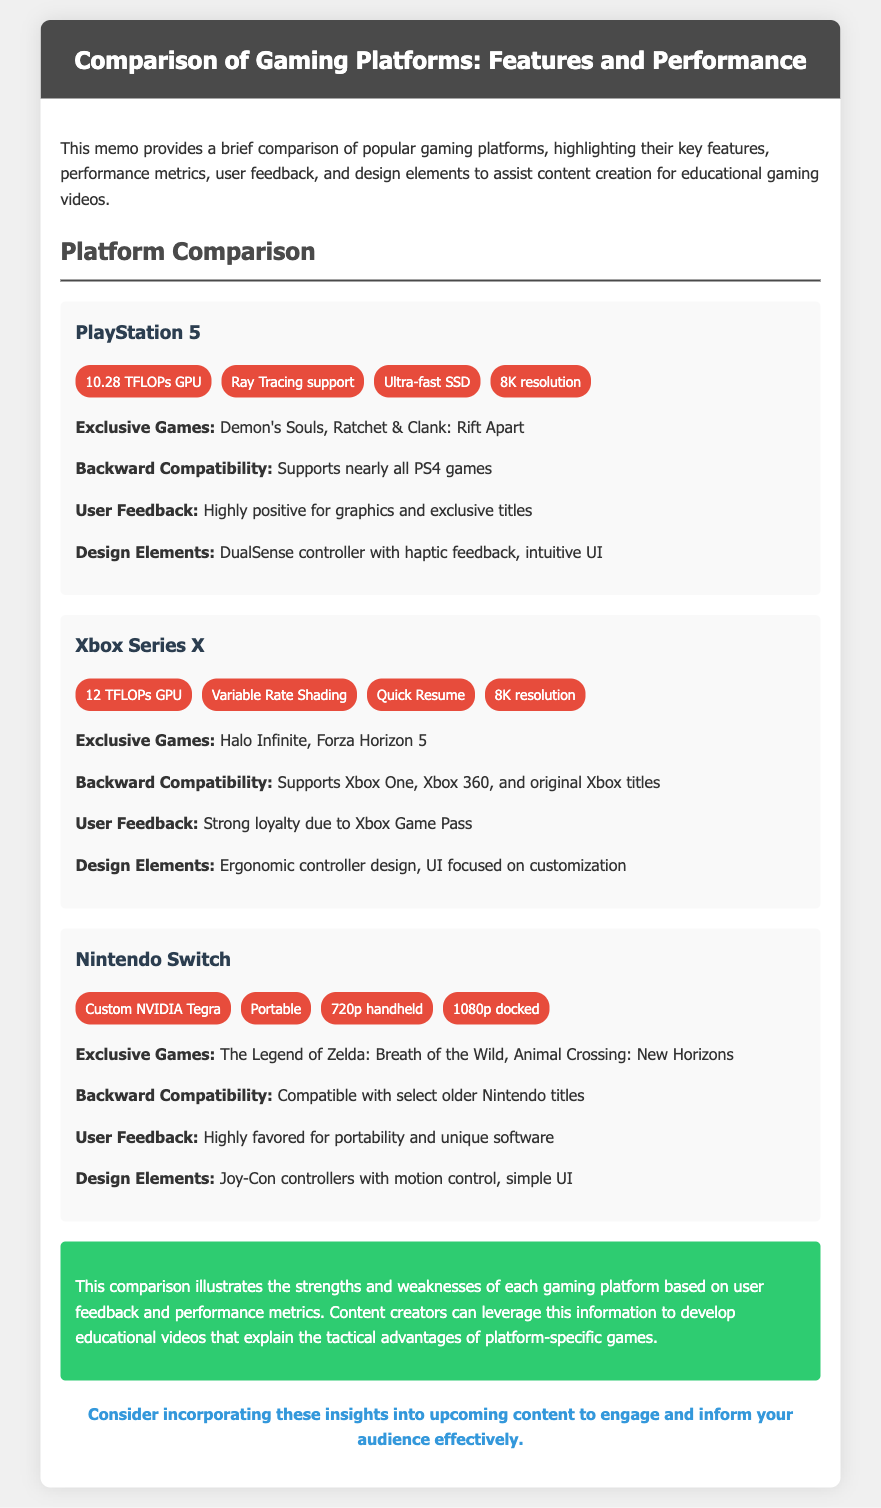What is the GPU power of PlayStation 5? The document lists the GPU power of PlayStation 5 as 10.28 TFLOPs.
Answer: 10.28 TFLOPs What exclusive game is mentioned for the Xbox Series X? The document specifically mentions Halo Infinite as an exclusive game for Xbox Series X.
Answer: Halo Infinite What is the maximum resolution supported by Xbox Series X? The document states that Xbox Series X supports up to 8K resolution.
Answer: 8K resolution Which platform is favored for its portability? The Nintendo Switch is highlighted in the document as being highly favored for its portability.
Answer: Nintendo Switch What feature allows quick game resuming on Xbox Series X? The feature "Quick Resume" is mentioned for Xbox Series X, facilitating quick game resuming.
Answer: Quick Resume Which platform has the most powerful GPU based on TFLOPs? The comparison shows Xbox Series X having the most powerful GPU with 12 TFLOPs.
Answer: 12 TFLOPs What design element does the PlayStation 5 utilize for enhanced feedback? The PlayStation 5 utilizes the DualSense controller with haptic feedback as a design element.
Answer: DualSense controller What factor contributes to strong loyalty for Xbox Series X? The document attributes strong loyalty for Xbox Series X to the Xbox Game Pass service.
Answer: Xbox Game Pass What summary insight does the conclusion provide for content creators? The conclusion indicates that the strengths and weaknesses of each platform can help content creators develop educational videos.
Answer: Develop educational videos 